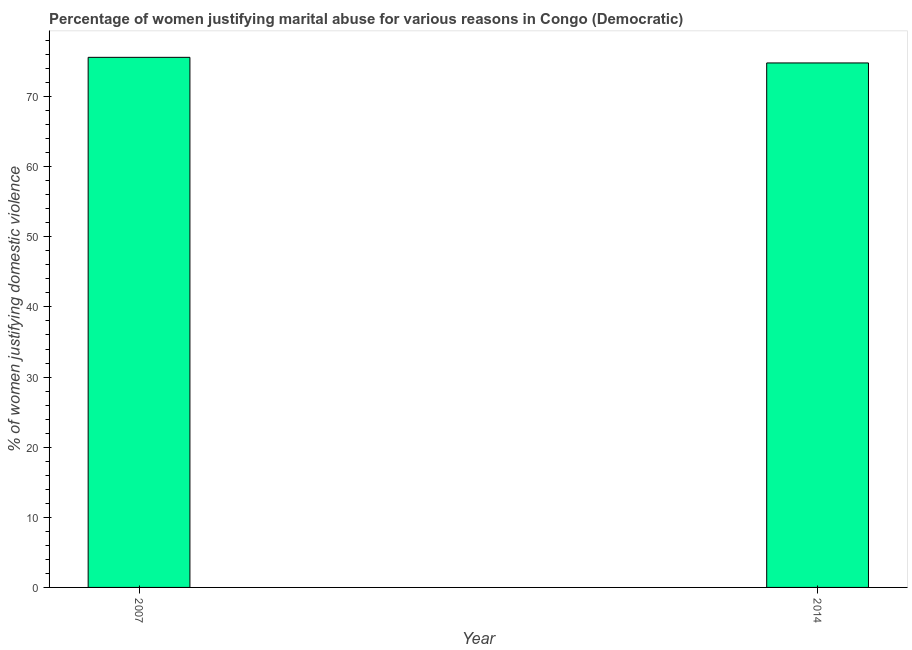Does the graph contain grids?
Give a very brief answer. No. What is the title of the graph?
Make the answer very short. Percentage of women justifying marital abuse for various reasons in Congo (Democratic). What is the label or title of the X-axis?
Provide a short and direct response. Year. What is the label or title of the Y-axis?
Your answer should be compact. % of women justifying domestic violence. What is the percentage of women justifying marital abuse in 2014?
Your answer should be very brief. 74.8. Across all years, what is the maximum percentage of women justifying marital abuse?
Offer a very short reply. 75.6. Across all years, what is the minimum percentage of women justifying marital abuse?
Give a very brief answer. 74.8. In which year was the percentage of women justifying marital abuse minimum?
Your response must be concise. 2014. What is the sum of the percentage of women justifying marital abuse?
Offer a very short reply. 150.4. What is the average percentage of women justifying marital abuse per year?
Your answer should be compact. 75.2. What is the median percentage of women justifying marital abuse?
Ensure brevity in your answer.  75.2. In how many years, is the percentage of women justifying marital abuse greater than 30 %?
Your response must be concise. 2. Do a majority of the years between 2014 and 2007 (inclusive) have percentage of women justifying marital abuse greater than 30 %?
Your answer should be very brief. No. What is the ratio of the percentage of women justifying marital abuse in 2007 to that in 2014?
Offer a very short reply. 1.01. How many bars are there?
Keep it short and to the point. 2. What is the difference between two consecutive major ticks on the Y-axis?
Your answer should be very brief. 10. What is the % of women justifying domestic violence in 2007?
Make the answer very short. 75.6. What is the % of women justifying domestic violence in 2014?
Provide a short and direct response. 74.8. What is the difference between the % of women justifying domestic violence in 2007 and 2014?
Your answer should be compact. 0.8. 